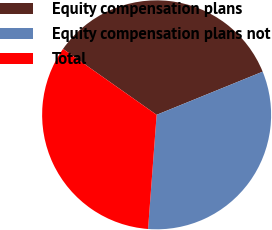Convert chart to OTSL. <chart><loc_0><loc_0><loc_500><loc_500><pie_chart><fcel>Equity compensation plans<fcel>Equity compensation plans not<fcel>Total<nl><fcel>34.09%<fcel>32.34%<fcel>33.57%<nl></chart> 